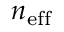Convert formula to latex. <formula><loc_0><loc_0><loc_500><loc_500>n _ { e f f }</formula> 